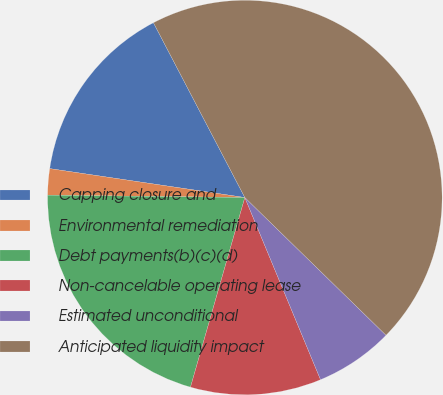<chart> <loc_0><loc_0><loc_500><loc_500><pie_chart><fcel>Capping closure and<fcel>Environmental remediation<fcel>Debt payments(b)(c)(d)<fcel>Non-cancelable operating lease<fcel>Estimated unconditional<fcel>Anticipated liquidity impact<nl><fcel>14.99%<fcel>2.15%<fcel>20.75%<fcel>10.71%<fcel>6.43%<fcel>44.97%<nl></chart> 